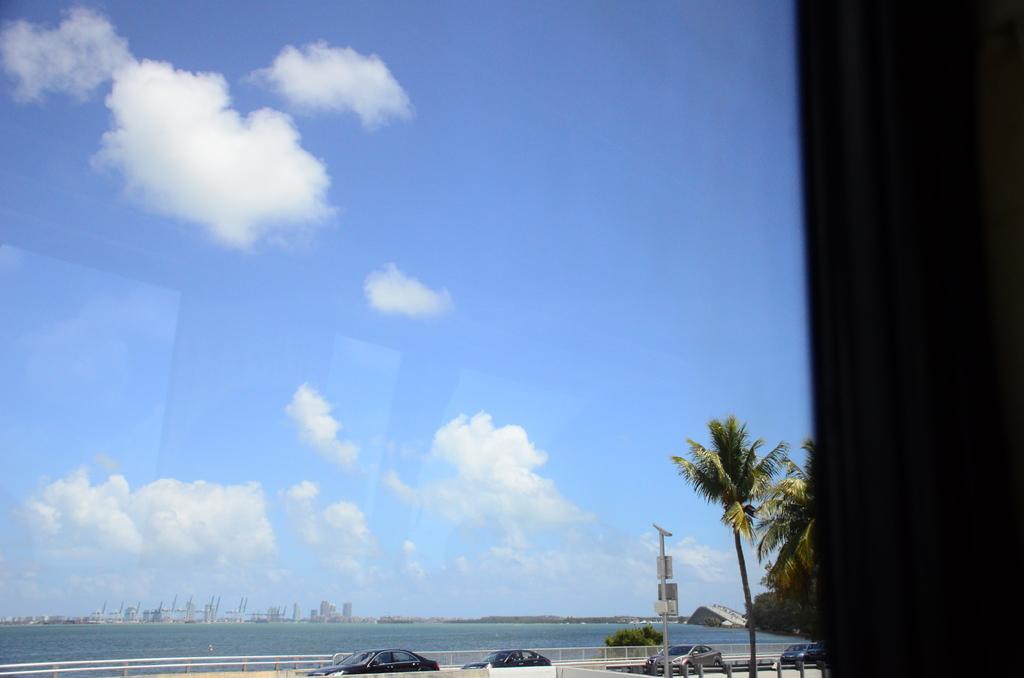In one or two sentences, can you explain what this image depicts? In the image we can see the buildings and there are vehicles. Here we can see barrier, trees, the sea and the cloudy pale blue sky. 